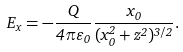<formula> <loc_0><loc_0><loc_500><loc_500>E _ { x } = - \frac { Q } { 4 \pi \varepsilon _ { 0 } } \frac { x _ { 0 } } { ( x _ { 0 } ^ { 2 } + z ^ { 2 } ) ^ { 3 / 2 } } .</formula> 